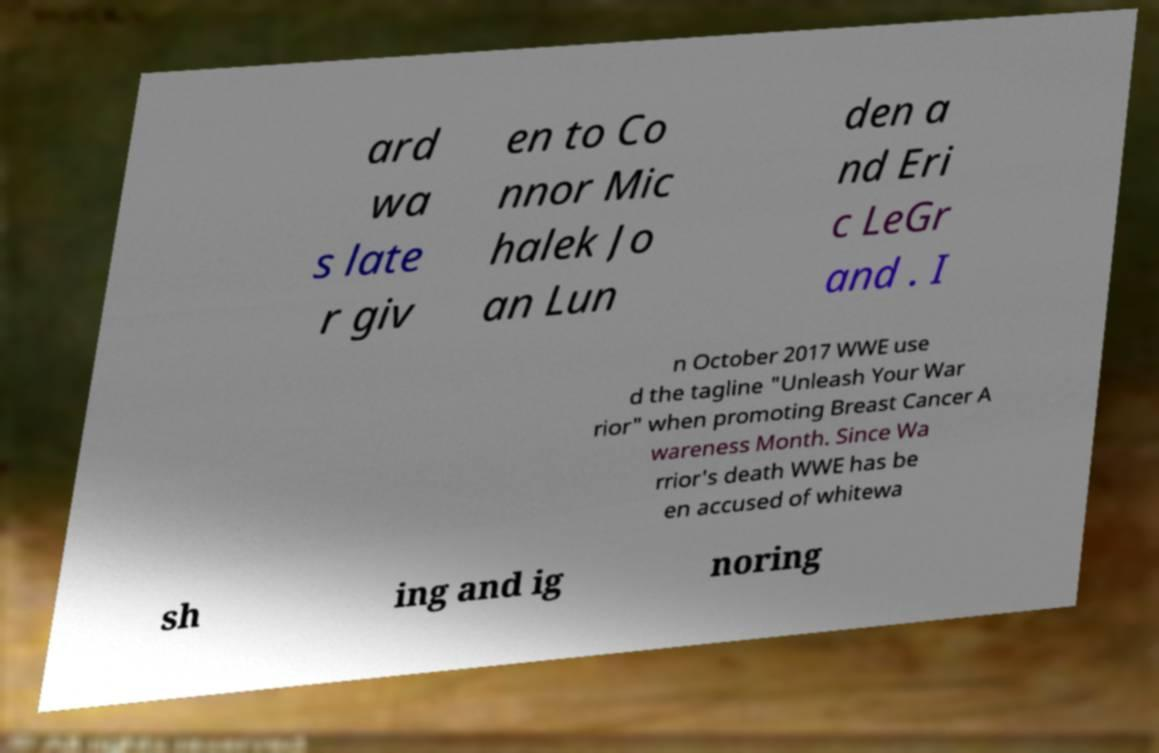What messages or text are displayed in this image? I need them in a readable, typed format. ard wa s late r giv en to Co nnor Mic halek Jo an Lun den a nd Eri c LeGr and . I n October 2017 WWE use d the tagline "Unleash Your War rior" when promoting Breast Cancer A wareness Month. Since Wa rrior's death WWE has be en accused of whitewa sh ing and ig noring 